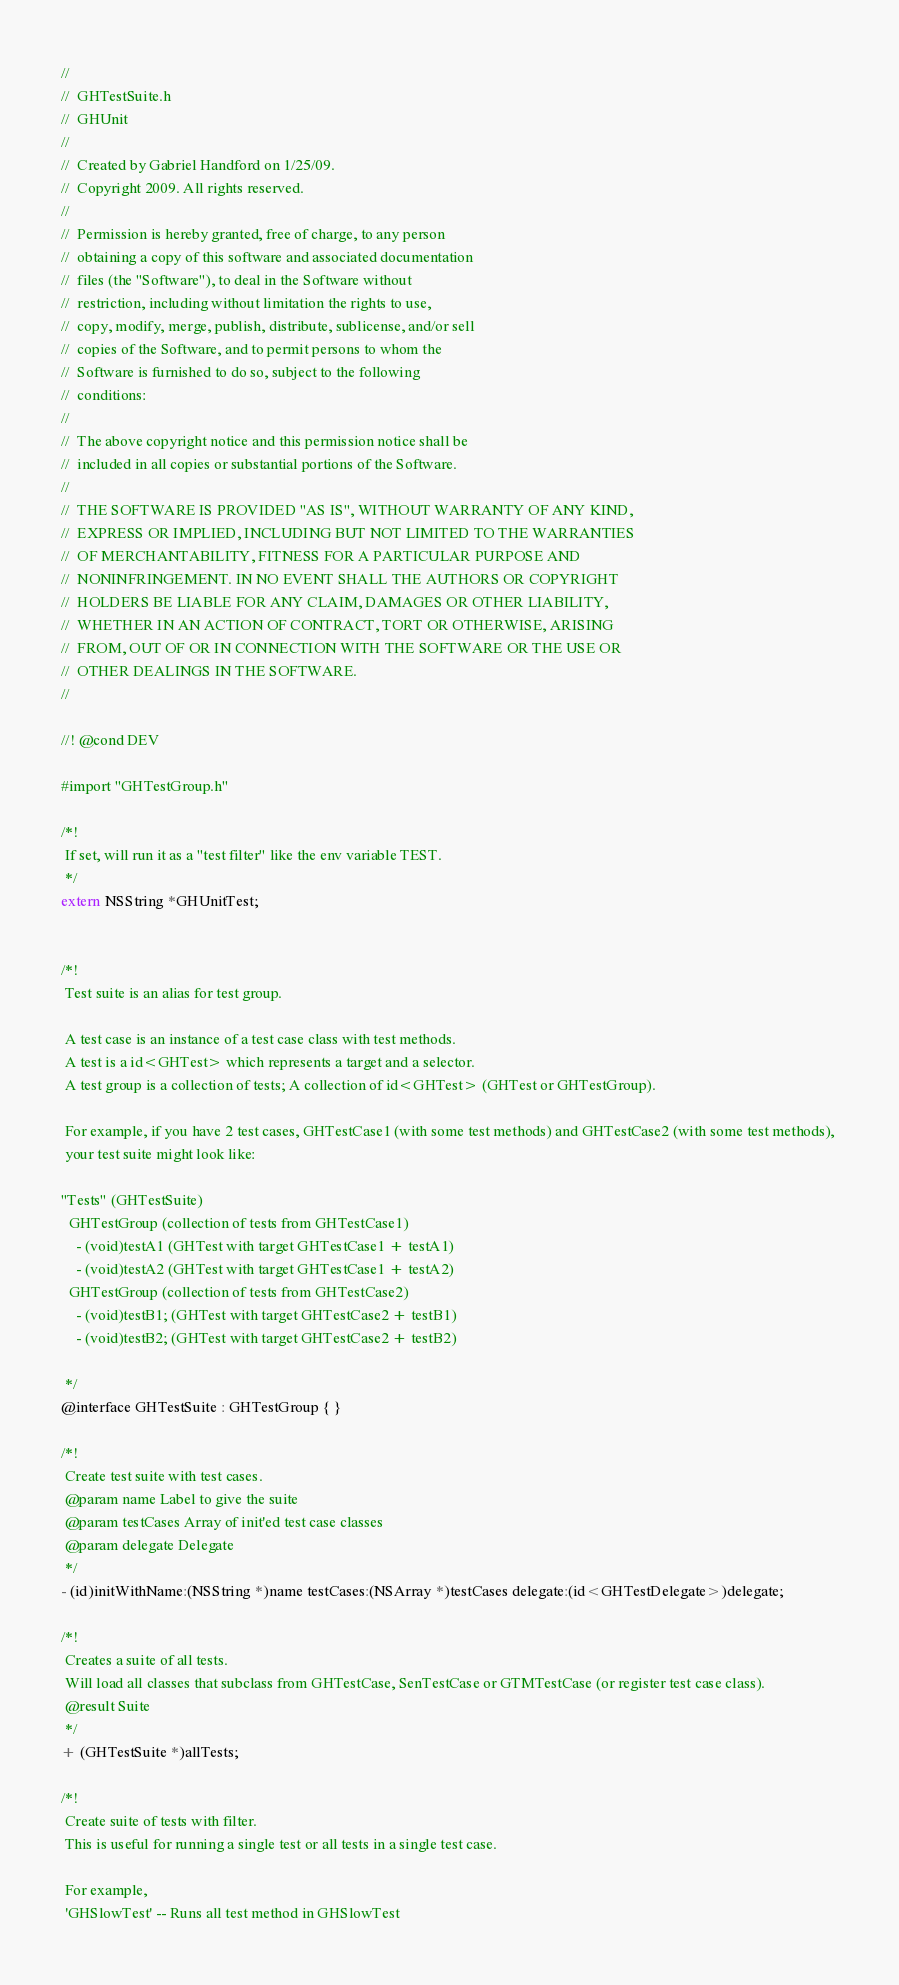<code> <loc_0><loc_0><loc_500><loc_500><_C_>//
//  GHTestSuite.h
//  GHUnit
//
//  Created by Gabriel Handford on 1/25/09.
//  Copyright 2009. All rights reserved.
//
//  Permission is hereby granted, free of charge, to any person
//  obtaining a copy of this software and associated documentation
//  files (the "Software"), to deal in the Software without
//  restriction, including without limitation the rights to use,
//  copy, modify, merge, publish, distribute, sublicense, and/or sell
//  copies of the Software, and to permit persons to whom the
//  Software is furnished to do so, subject to the following
//  conditions:
//
//  The above copyright notice and this permission notice shall be
//  included in all copies or substantial portions of the Software.
//
//  THE SOFTWARE IS PROVIDED "AS IS", WITHOUT WARRANTY OF ANY KIND,
//  EXPRESS OR IMPLIED, INCLUDING BUT NOT LIMITED TO THE WARRANTIES
//  OF MERCHANTABILITY, FITNESS FOR A PARTICULAR PURPOSE AND
//  NONINFRINGEMENT. IN NO EVENT SHALL THE AUTHORS OR COPYRIGHT
//  HOLDERS BE LIABLE FOR ANY CLAIM, DAMAGES OR OTHER LIABILITY,
//  WHETHER IN AN ACTION OF CONTRACT, TORT OR OTHERWISE, ARISING
//  FROM, OUT OF OR IN CONNECTION WITH THE SOFTWARE OR THE USE OR
//  OTHER DEALINGS IN THE SOFTWARE.
//

//! @cond DEV

#import "GHTestGroup.h"

/*!
 If set, will run it as a "test filter" like the env variable TEST.
 */
extern NSString *GHUnitTest;


/*!
 Test suite is an alias for test group.
 
 A test case is an instance of a test case class with test methods.
 A test is a id<GHTest> which represents a target and a selector.
 A test group is a collection of tests; A collection of id<GHTest> (GHTest or GHTestGroup).
 
 For example, if you have 2 test cases, GHTestCase1 (with some test methods) and GHTestCase2 (with some test methods), 
 your test suite might look like:
 
"Tests" (GHTestSuite)
  GHTestGroup (collection of tests from GHTestCase1)
    - (void)testA1 (GHTest with target GHTestCase1 + testA1)
    - (void)testA2 (GHTest with target GHTestCase1 + testA2)
  GHTestGroup (collection of tests from GHTestCase2)
    - (void)testB1; (GHTest with target GHTestCase2 + testB1)
    - (void)testB2; (GHTest with target GHTestCase2 + testB2)  
 
 */
@interface GHTestSuite : GHTestGroup { }

/*! 
 Create test suite with test cases.
 @param name Label to give the suite
 @param testCases Array of init'ed test case classes
 @param delegate Delegate
 */
- (id)initWithName:(NSString *)name testCases:(NSArray *)testCases delegate:(id<GHTestDelegate>)delegate;

/*!
 Creates a suite of all tests.
 Will load all classes that subclass from GHTestCase, SenTestCase or GTMTestCase (or register test case class).
 @result Suite
 */
+ (GHTestSuite *)allTests;

/*!
 Create suite of tests with filter.
 This is useful for running a single test or all tests in a single test case.
 
 For example,
 'GHSlowTest' -- Runs all test method in GHSlowTest</code> 